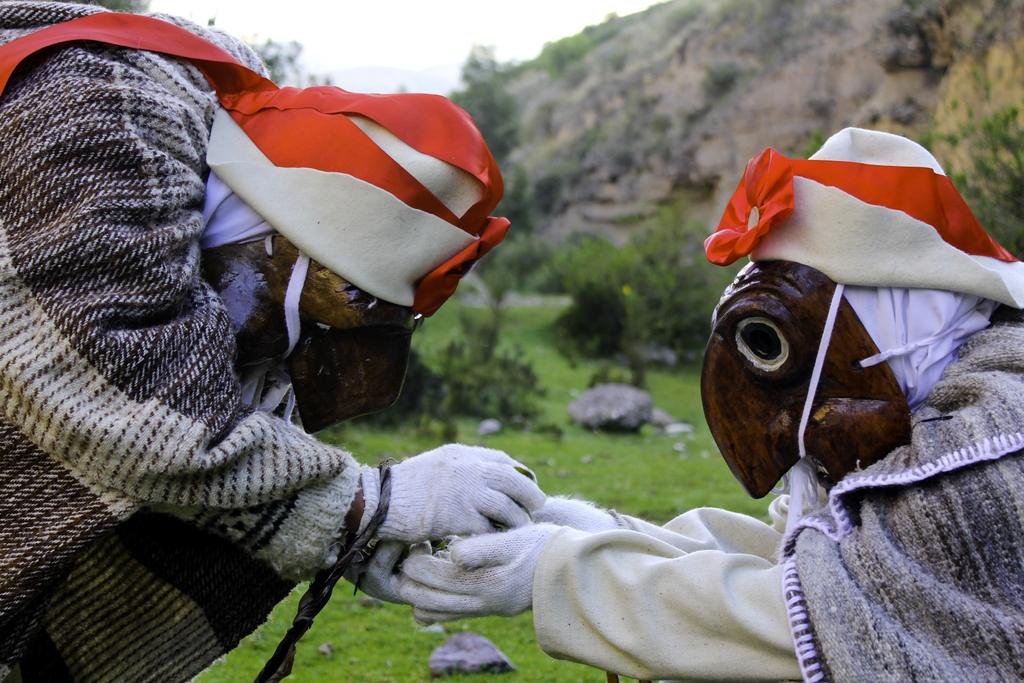How many people are in the image? There are two persons in the image. What are the persons wearing? The persons are wearing costumes. What can be seen in the background of the image? There are trees and mountains in the background of the image. What is the color of the trees in the image? The trees are green in color. What is the color of the sky in the image? The sky is white in color. How many chairs are visible in the image? There are no chairs present in the image. What type of hole can be seen in the costume of the person on the left? There is no hole visible in the costume of the person on the left; they are wearing a full costume. 